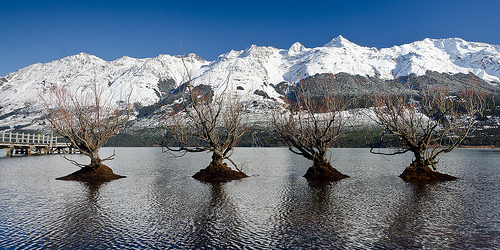<image>
Is there a tree one in front of the tree two? No. The tree one is not in front of the tree two. The spatial positioning shows a different relationship between these objects. 